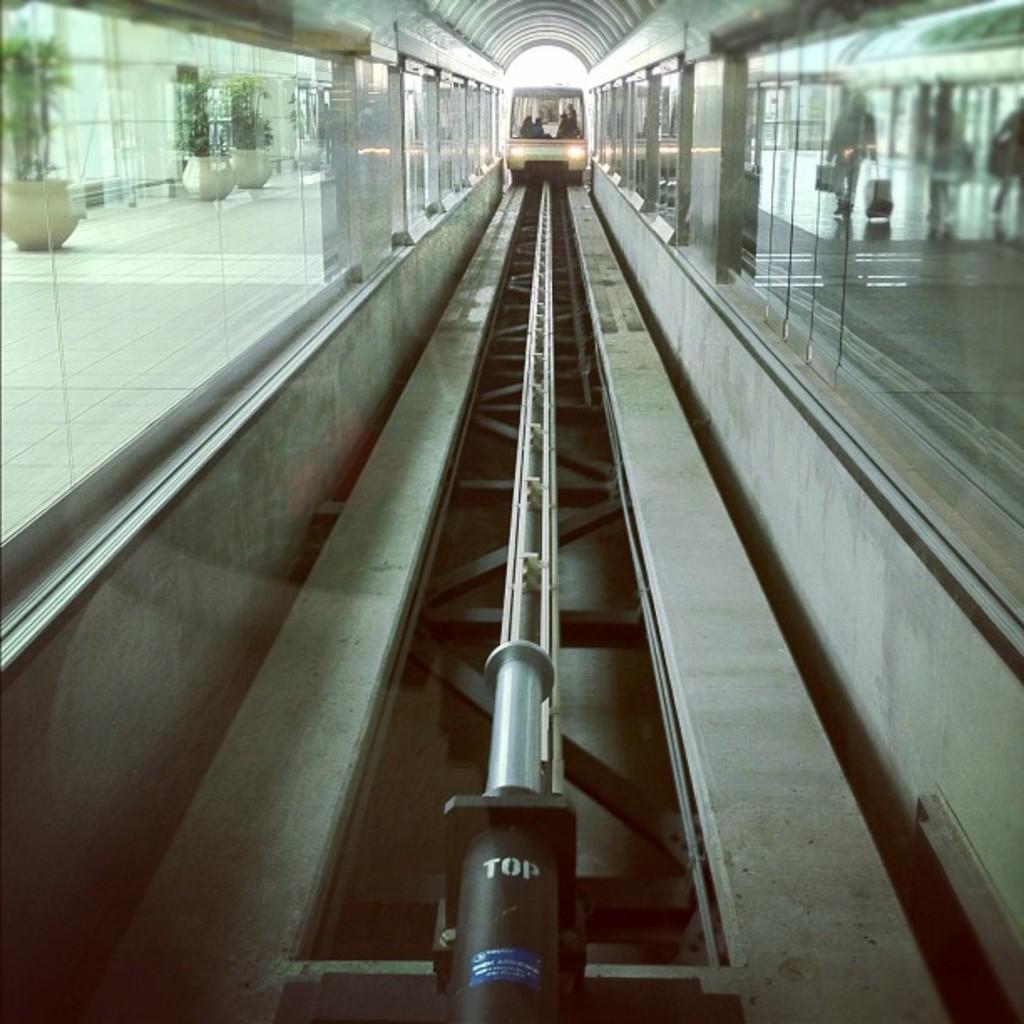Describe this image in one or two sentences. In this image I can see the train on the track and I can see few glass walls. In the background I can see few plants in green color. 